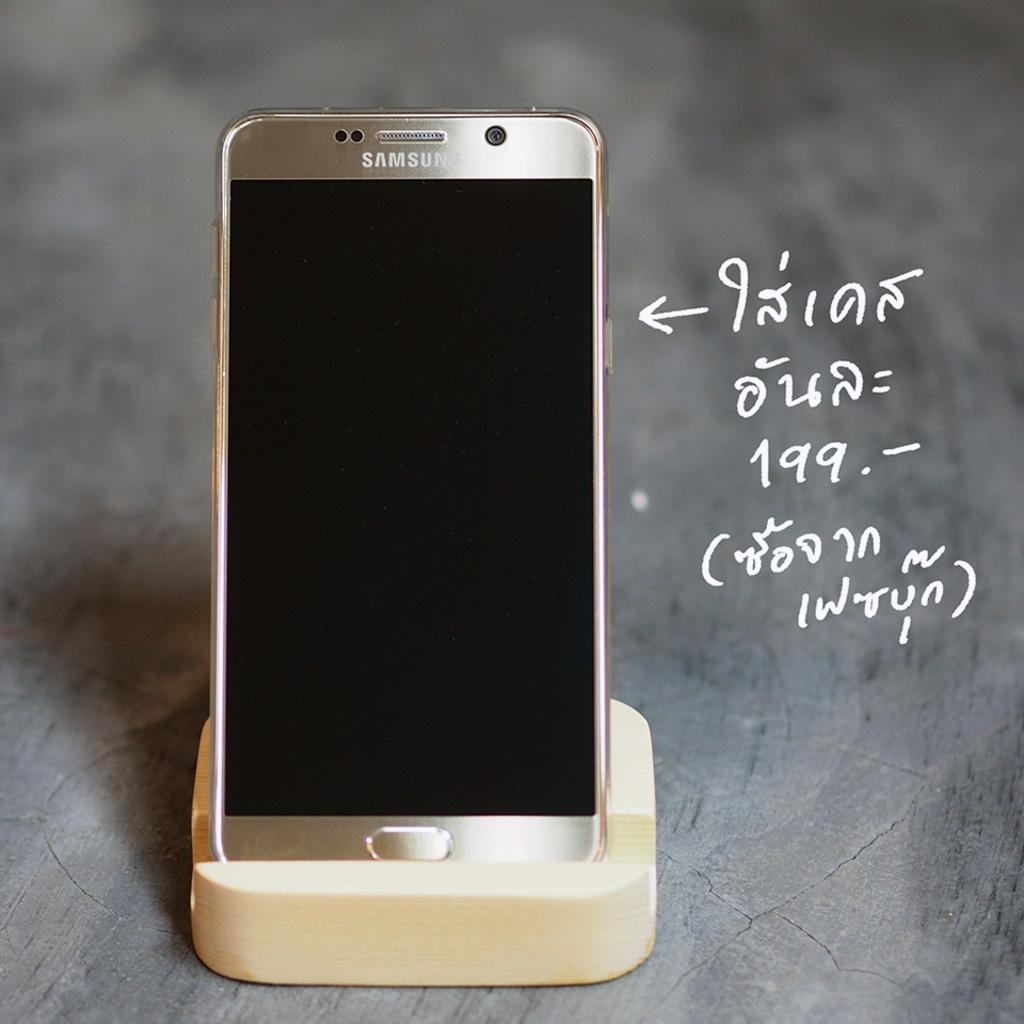What electronic device is present in the image? There is a cell phone in the image. How is the cell phone positioned in the image? The cell phone is placed on a cell phone stand. What can be seen on the right side of the image? There is text on the right side of the image. What surface is visible at the bottom of the image? There is a floor visible at the bottom of the image. How many men are holding the flag in the image? There is no flag or men present in the image. 